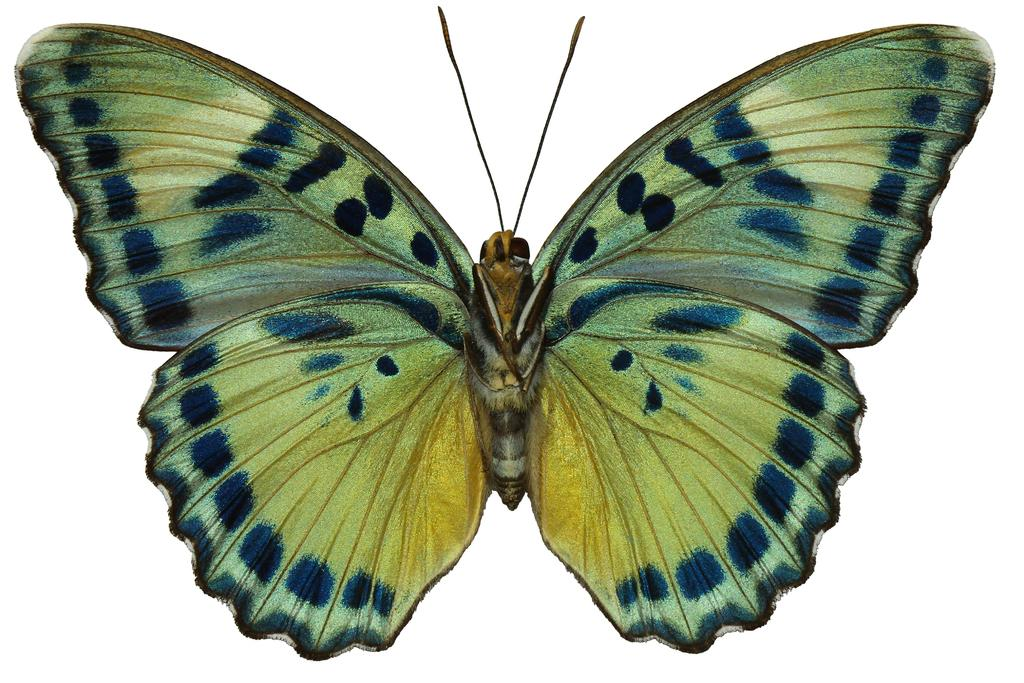What is the main subject of the image? There is a butterfly in the image. What can be seen in the background of the image? The background of the image is white. What type of whip can be seen in the image? There is no whip present in the image; it features a butterfly against a white background. 